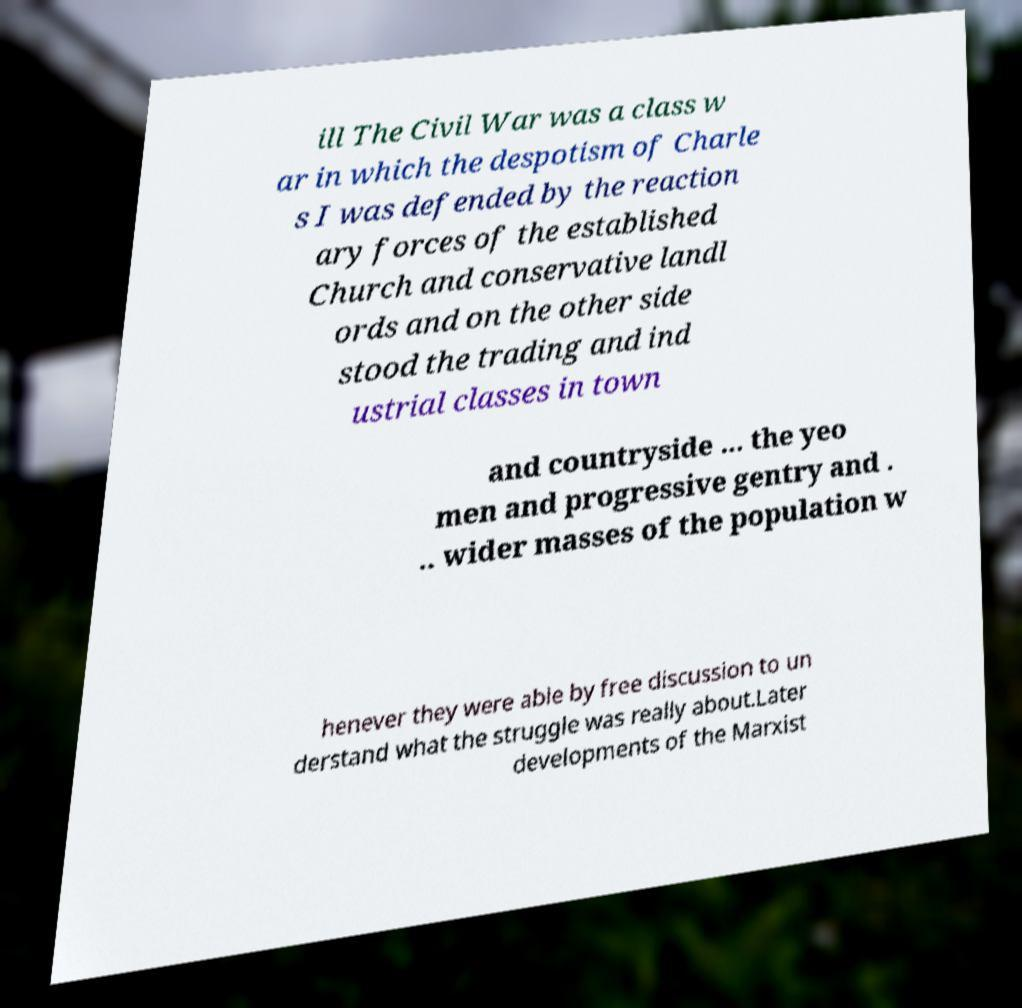Please read and relay the text visible in this image. What does it say? ill The Civil War was a class w ar in which the despotism of Charle s I was defended by the reaction ary forces of the established Church and conservative landl ords and on the other side stood the trading and ind ustrial classes in town and countryside ... the yeo men and progressive gentry and . .. wider masses of the population w henever they were able by free discussion to un derstand what the struggle was really about.Later developments of the Marxist 